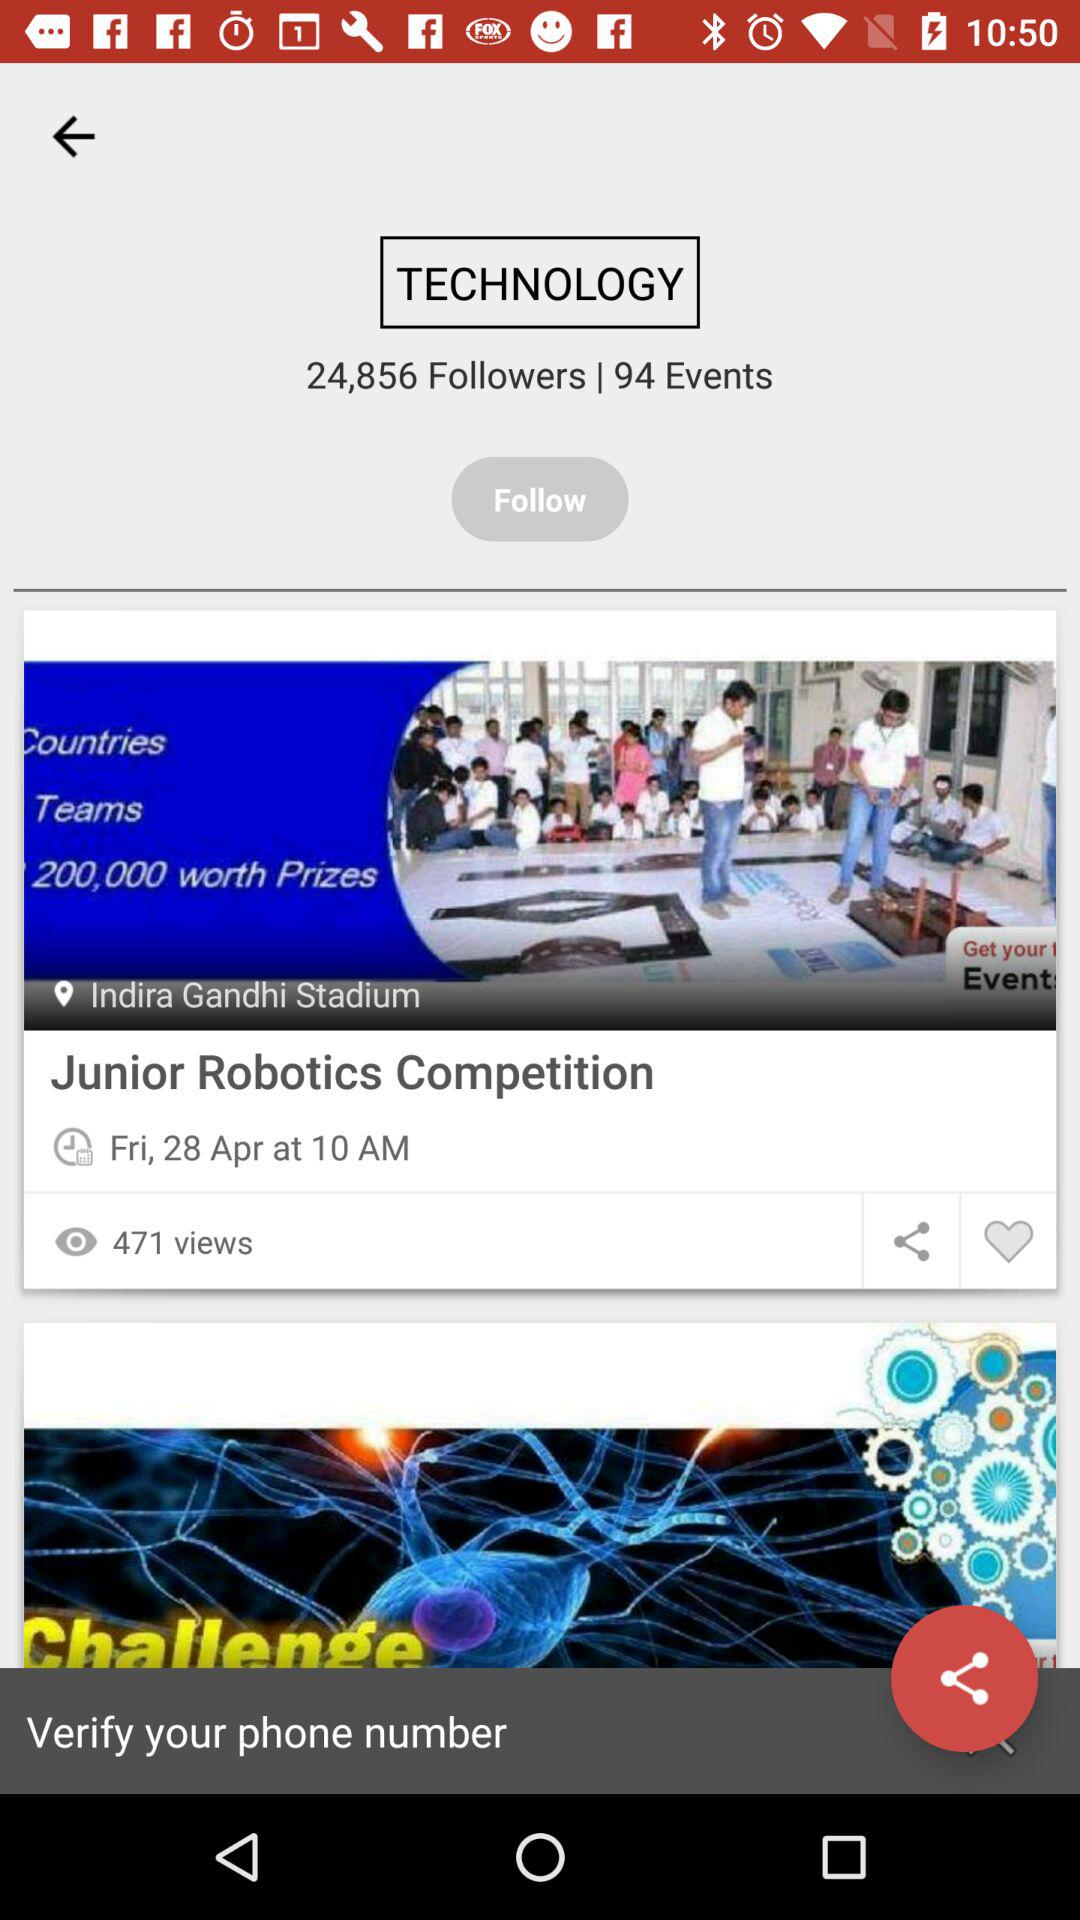What is the date of the "Junior Robotics Competition"? The date is Friday, April 28. 